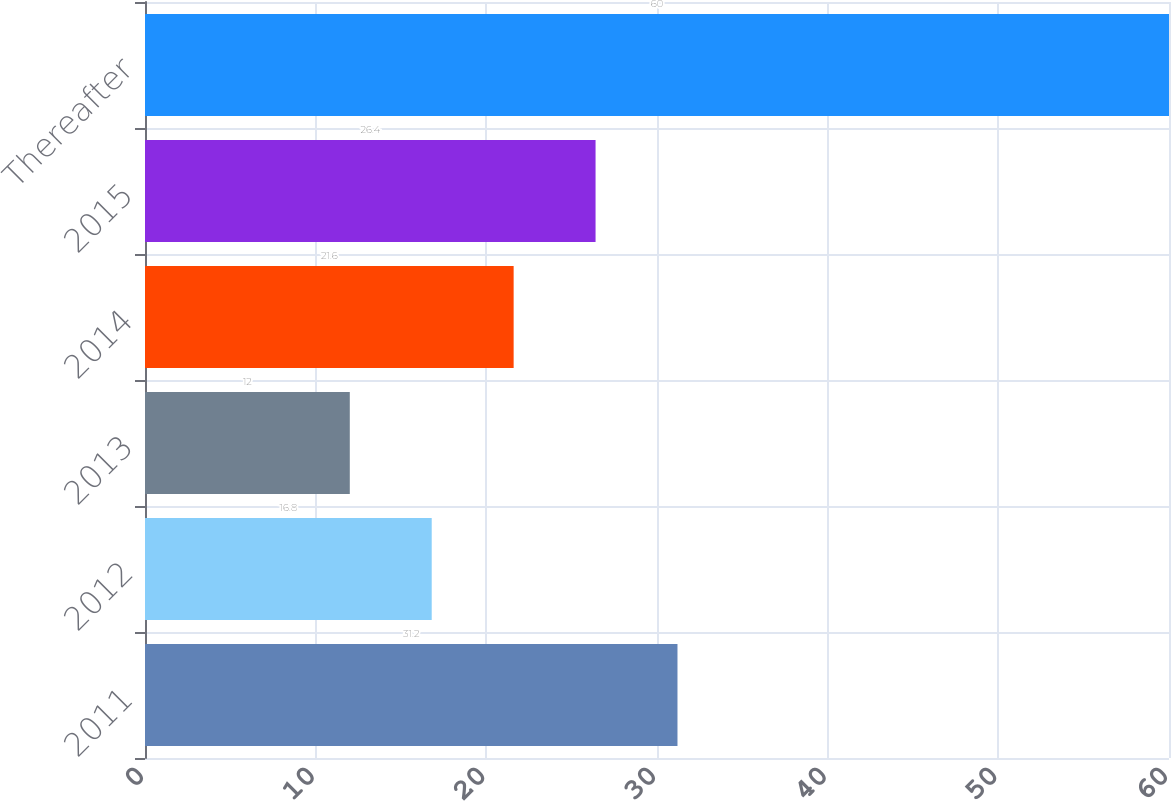<chart> <loc_0><loc_0><loc_500><loc_500><bar_chart><fcel>2011<fcel>2012<fcel>2013<fcel>2014<fcel>2015<fcel>Thereafter<nl><fcel>31.2<fcel>16.8<fcel>12<fcel>21.6<fcel>26.4<fcel>60<nl></chart> 